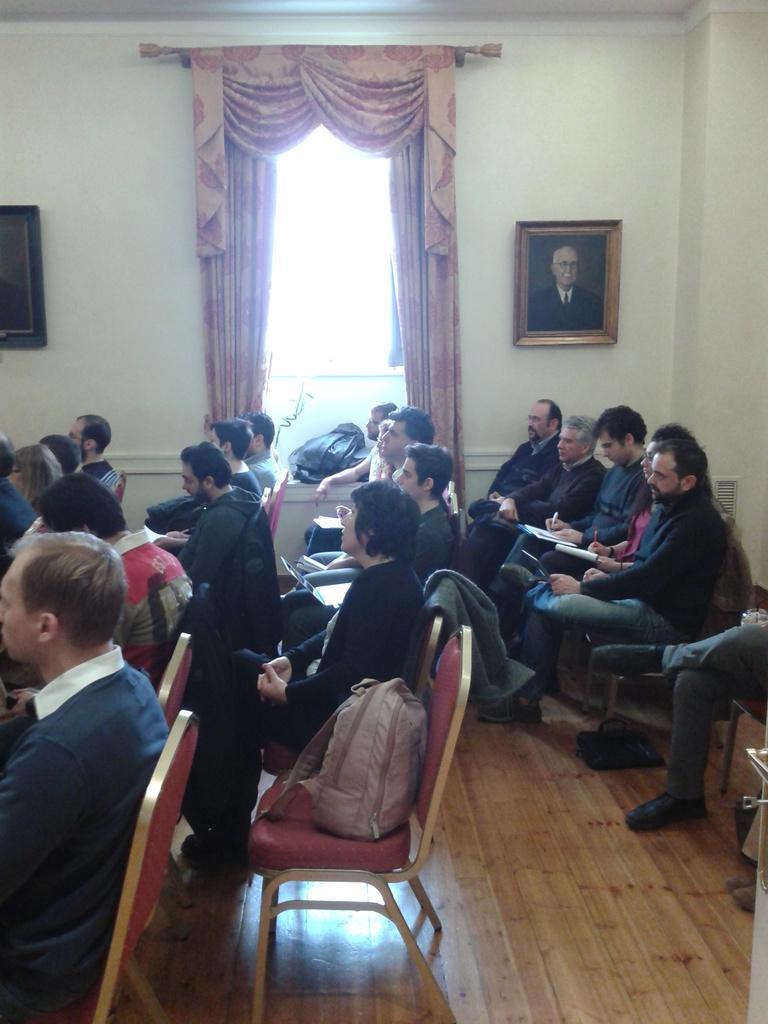Please provide a concise description of this image. In this picture there are people sitting on the chair and this is a bag placed on the chair and there is a photo frame on to the right and photo frame on to the left, there is a window and also a curtain 